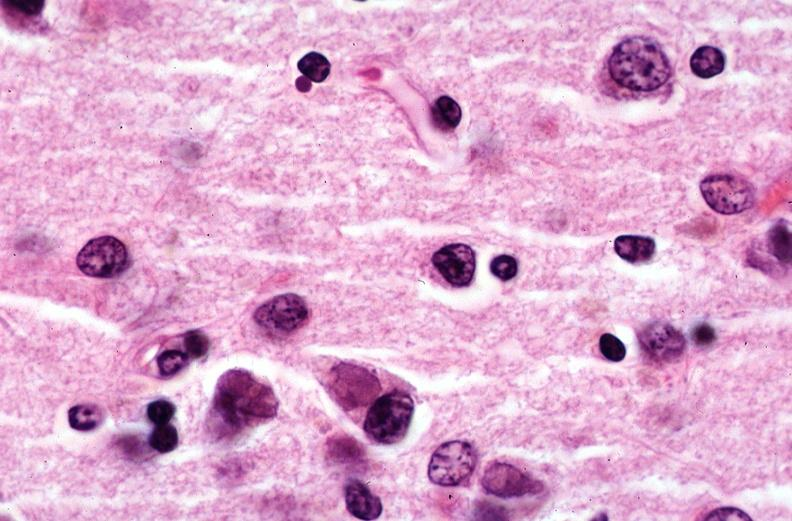where is this?
Answer the question using a single word or phrase. Nervous 